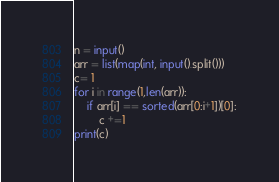<code> <loc_0><loc_0><loc_500><loc_500><_Python_>n = input()
arr = list(map(int, input().split()))
c= 1
for i in range(1,len(arr)):
    if arr[i] == sorted(arr[0:i+1])[0]:
        c +=1
print(c)</code> 